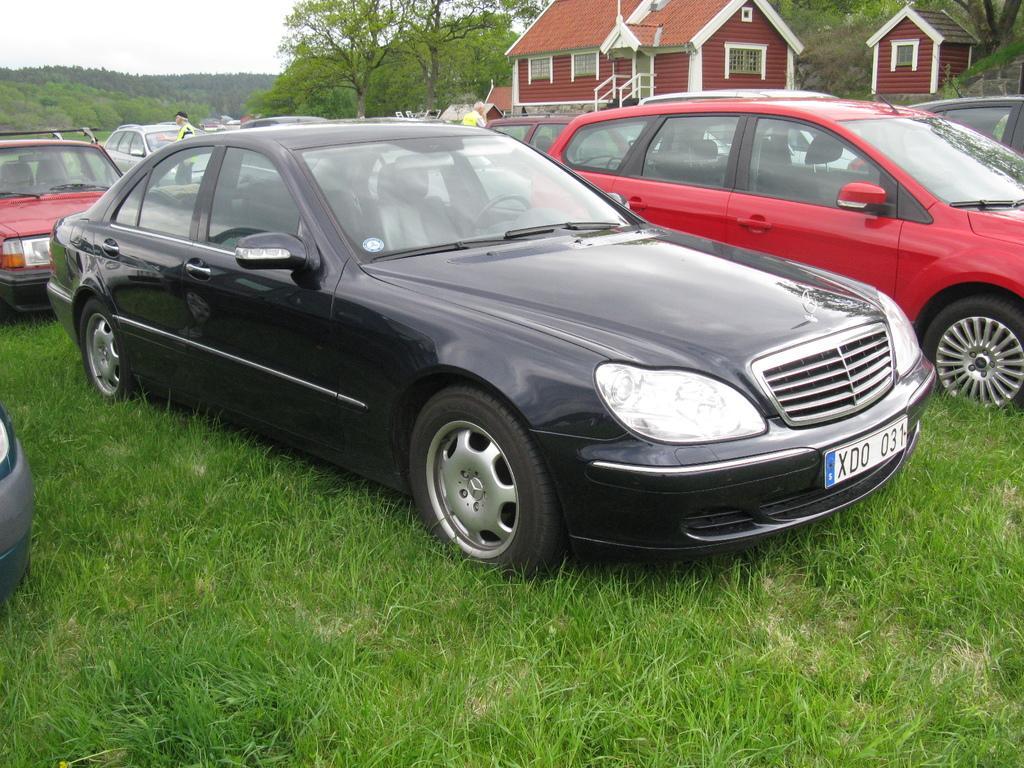In one or two sentences, can you explain what this image depicts? In this picture we can see a few vehicles on the grass. We can see some people at the back. There is a house and few trees in the background. 